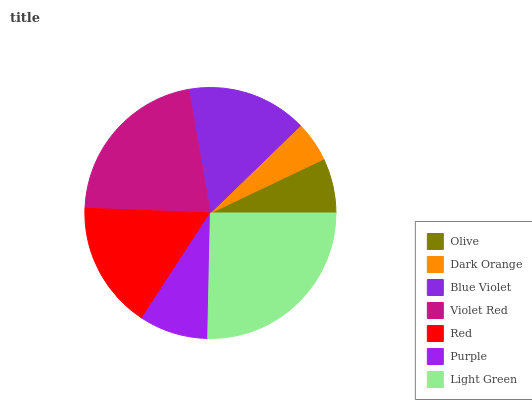Is Dark Orange the minimum?
Answer yes or no. Yes. Is Light Green the maximum?
Answer yes or no. Yes. Is Blue Violet the minimum?
Answer yes or no. No. Is Blue Violet the maximum?
Answer yes or no. No. Is Blue Violet greater than Dark Orange?
Answer yes or no. Yes. Is Dark Orange less than Blue Violet?
Answer yes or no. Yes. Is Dark Orange greater than Blue Violet?
Answer yes or no. No. Is Blue Violet less than Dark Orange?
Answer yes or no. No. Is Blue Violet the high median?
Answer yes or no. Yes. Is Blue Violet the low median?
Answer yes or no. Yes. Is Violet Red the high median?
Answer yes or no. No. Is Light Green the low median?
Answer yes or no. No. 